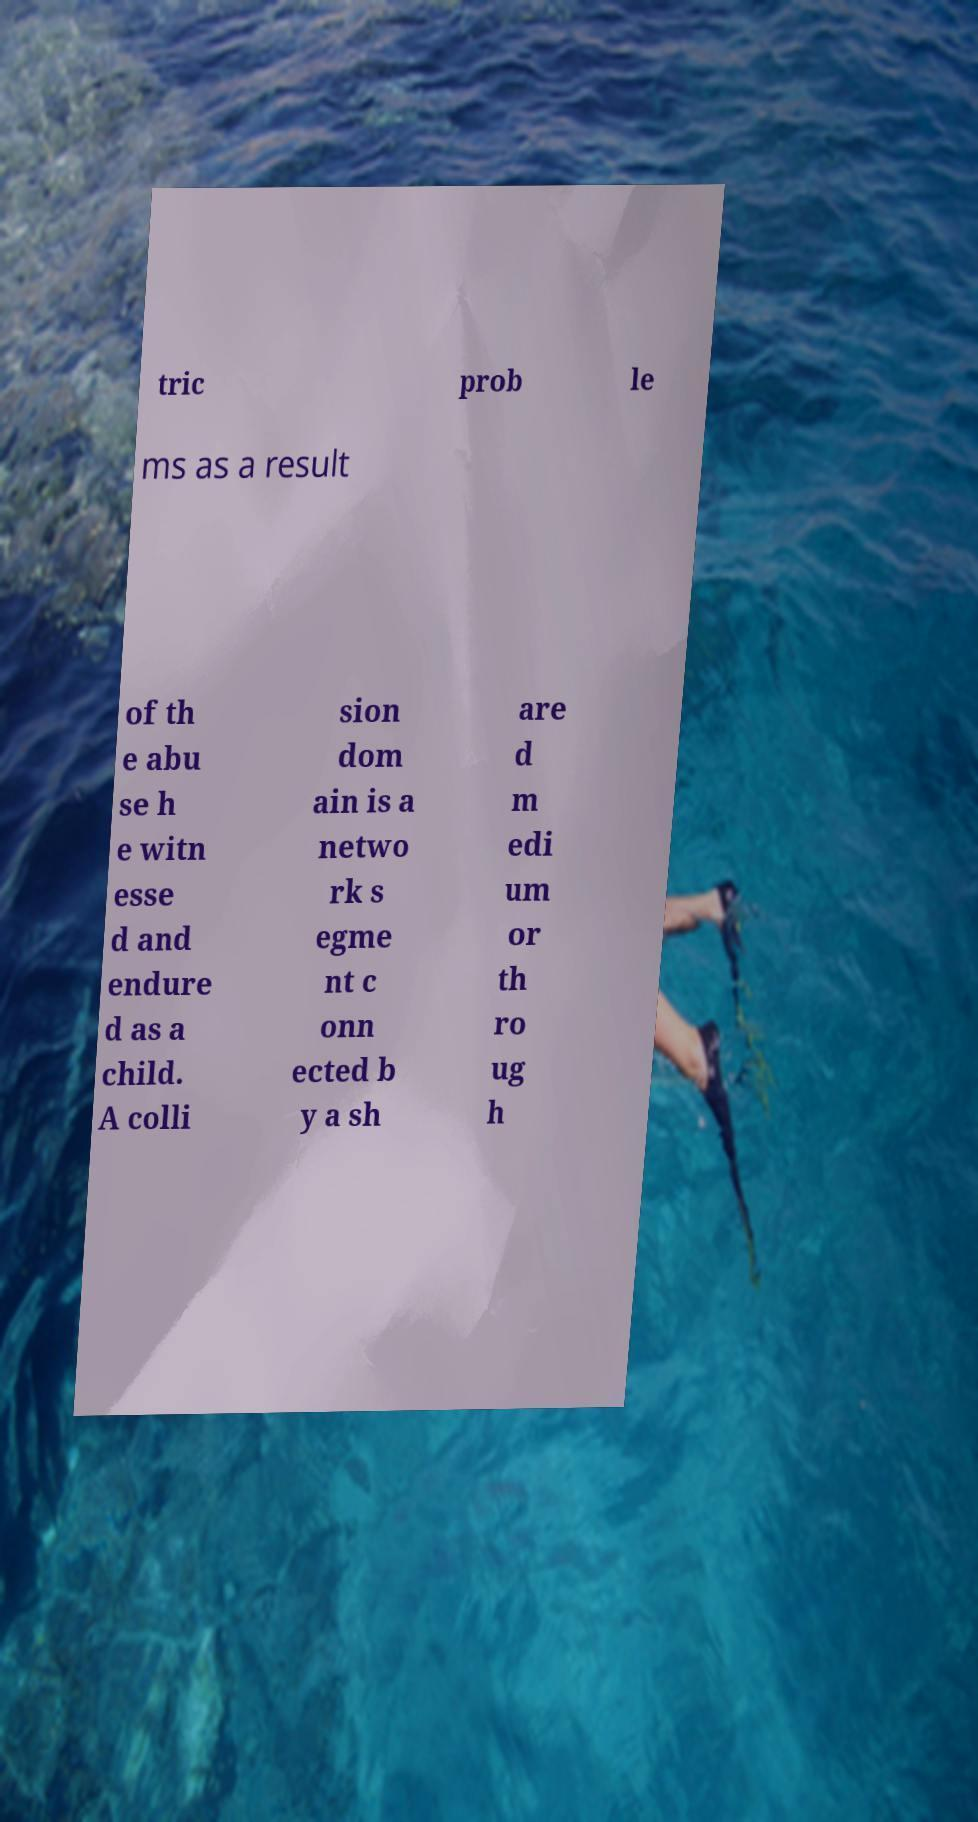Could you assist in decoding the text presented in this image and type it out clearly? tric prob le ms as a result of th e abu se h e witn esse d and endure d as a child. A colli sion dom ain is a netwo rk s egme nt c onn ected b y a sh are d m edi um or th ro ug h 